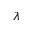Convert formula to latex. <formula><loc_0><loc_0><loc_500><loc_500>\lambda</formula> 